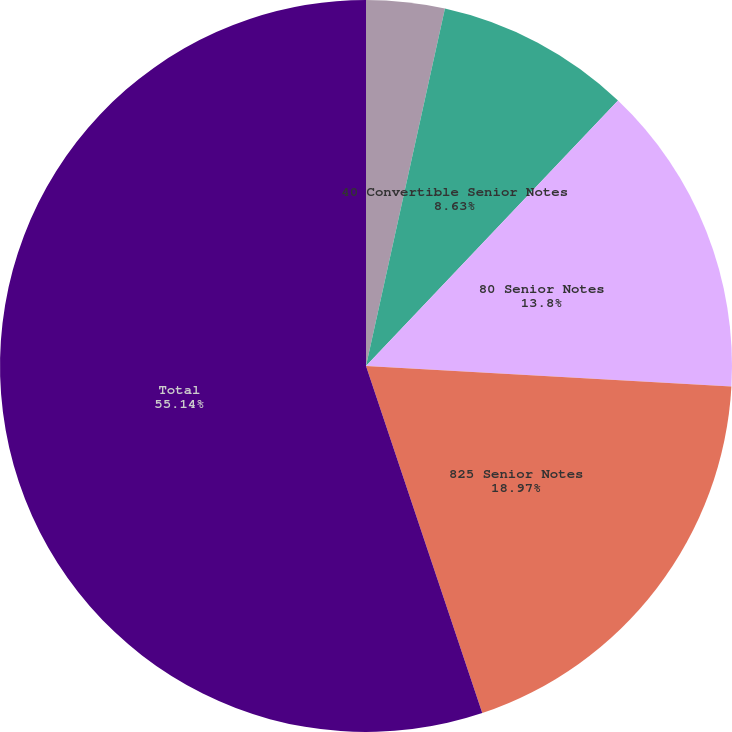Convert chart. <chart><loc_0><loc_0><loc_500><loc_500><pie_chart><fcel>1875 Convertible Senior Notes<fcel>40 Convertible Senior Notes<fcel>80 Senior Notes<fcel>825 Senior Notes<fcel>Total<nl><fcel>3.46%<fcel>8.63%<fcel>13.8%<fcel>18.97%<fcel>55.15%<nl></chart> 